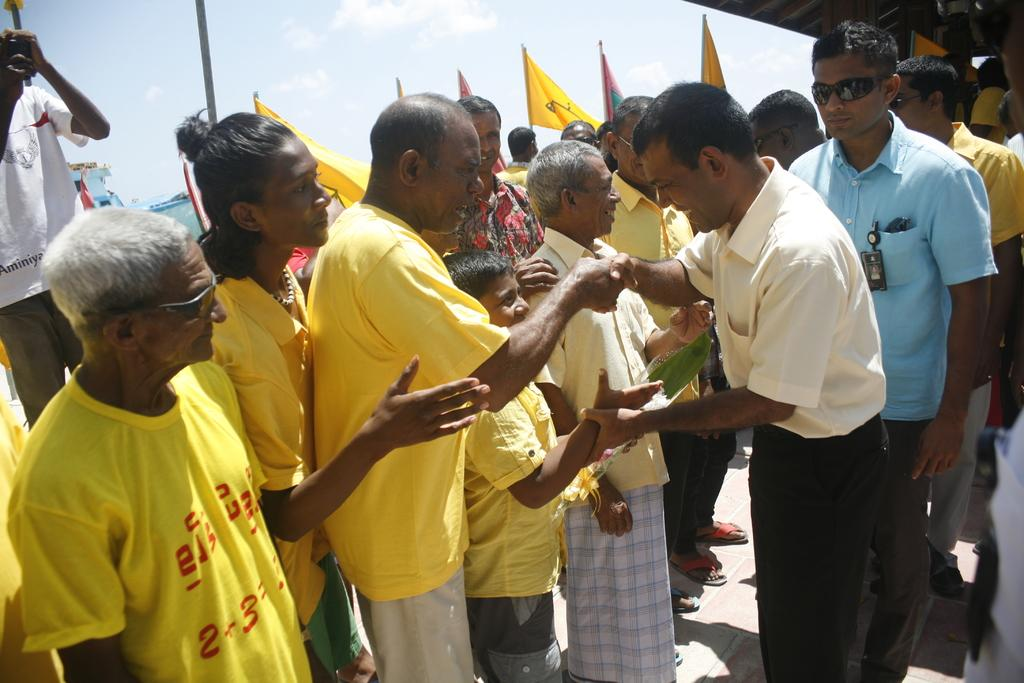How many people are present in the image? There are many people standing in the image. What are the people wearing? The people are wearing clothes. What can be seen besides the people in the image? There are many flags and a pole in the image. What is visible in the background of the image? The sky is visible in the image. What type of hook can be seen hanging from the pole in the image? There is no hook present on the pole in the image. 